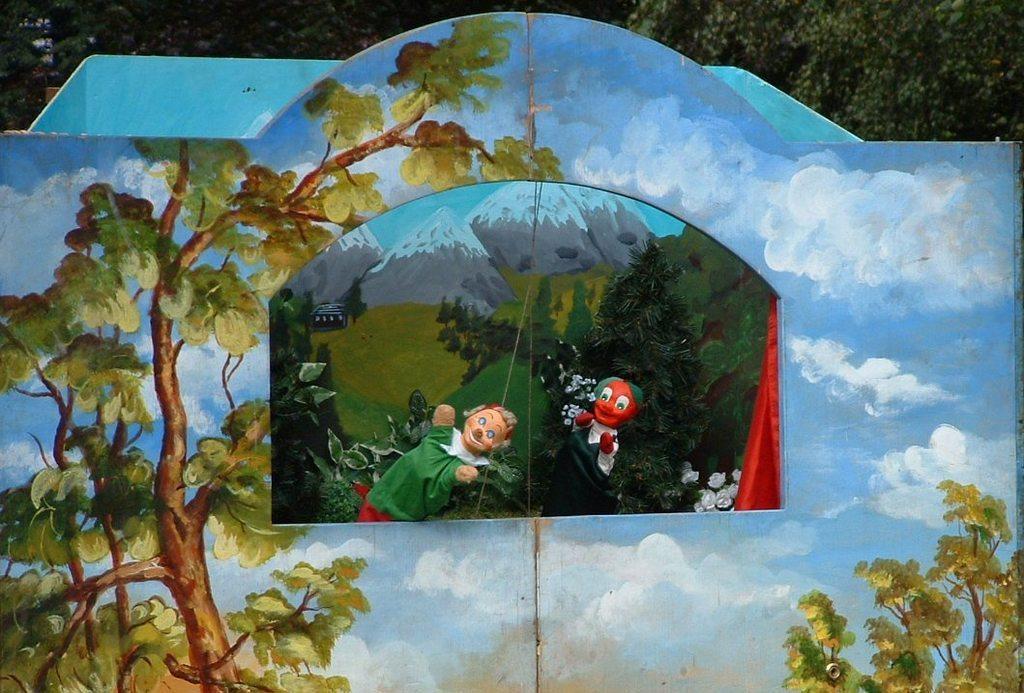How would you summarize this image in a sentence or two? In this picture we can see a painting and in this painting we can see toys, mountains, trees. 